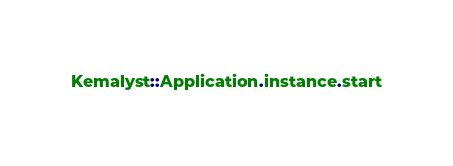<code> <loc_0><loc_0><loc_500><loc_500><_Crystal_>Kemalyst::Application.instance.start
</code> 